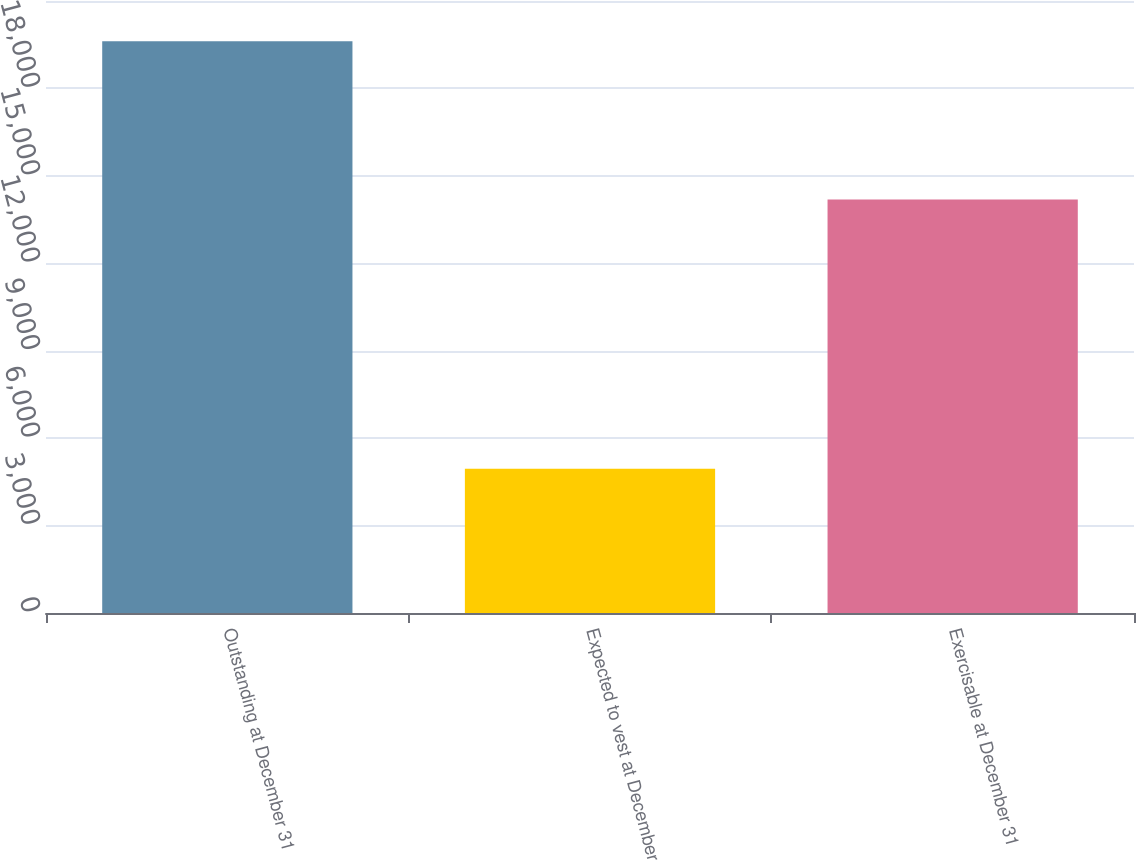Convert chart to OTSL. <chart><loc_0><loc_0><loc_500><loc_500><bar_chart><fcel>Outstanding at December 31<fcel>Expected to vest at December<fcel>Exercisable at December 31<nl><fcel>19619<fcel>4950<fcel>14193<nl></chart> 